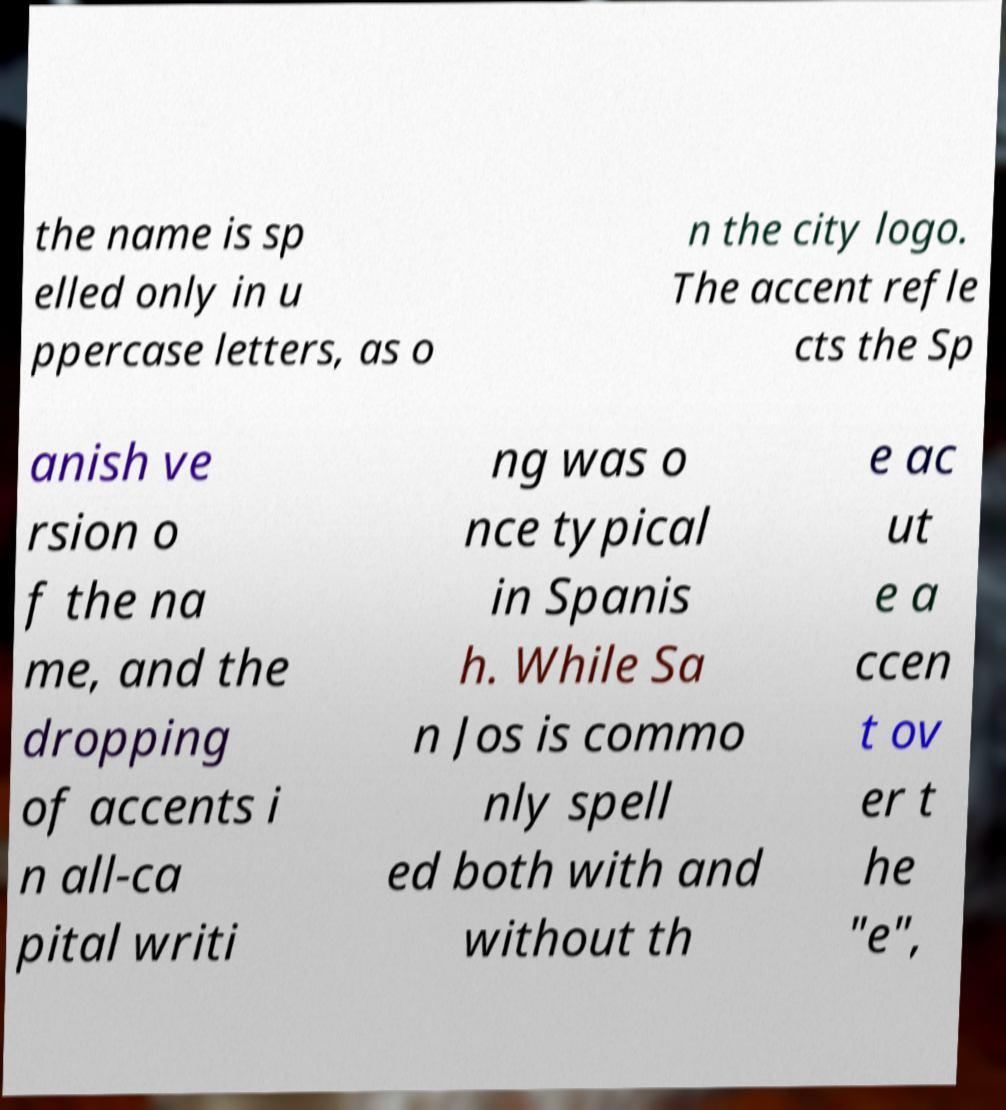Please identify and transcribe the text found in this image. the name is sp elled only in u ppercase letters, as o n the city logo. The accent refle cts the Sp anish ve rsion o f the na me, and the dropping of accents i n all-ca pital writi ng was o nce typical in Spanis h. While Sa n Jos is commo nly spell ed both with and without th e ac ut e a ccen t ov er t he "e", 